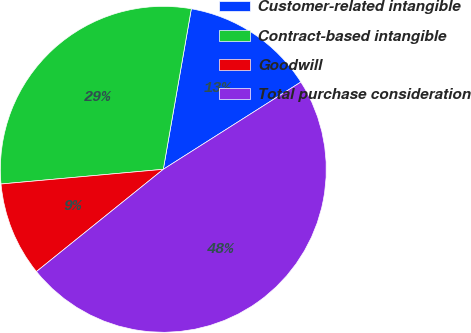Convert chart to OTSL. <chart><loc_0><loc_0><loc_500><loc_500><pie_chart><fcel>Customer-related intangible<fcel>Contract-based intangible<fcel>Goodwill<fcel>Total purchase consideration<nl><fcel>13.25%<fcel>29.19%<fcel>9.36%<fcel>48.2%<nl></chart> 